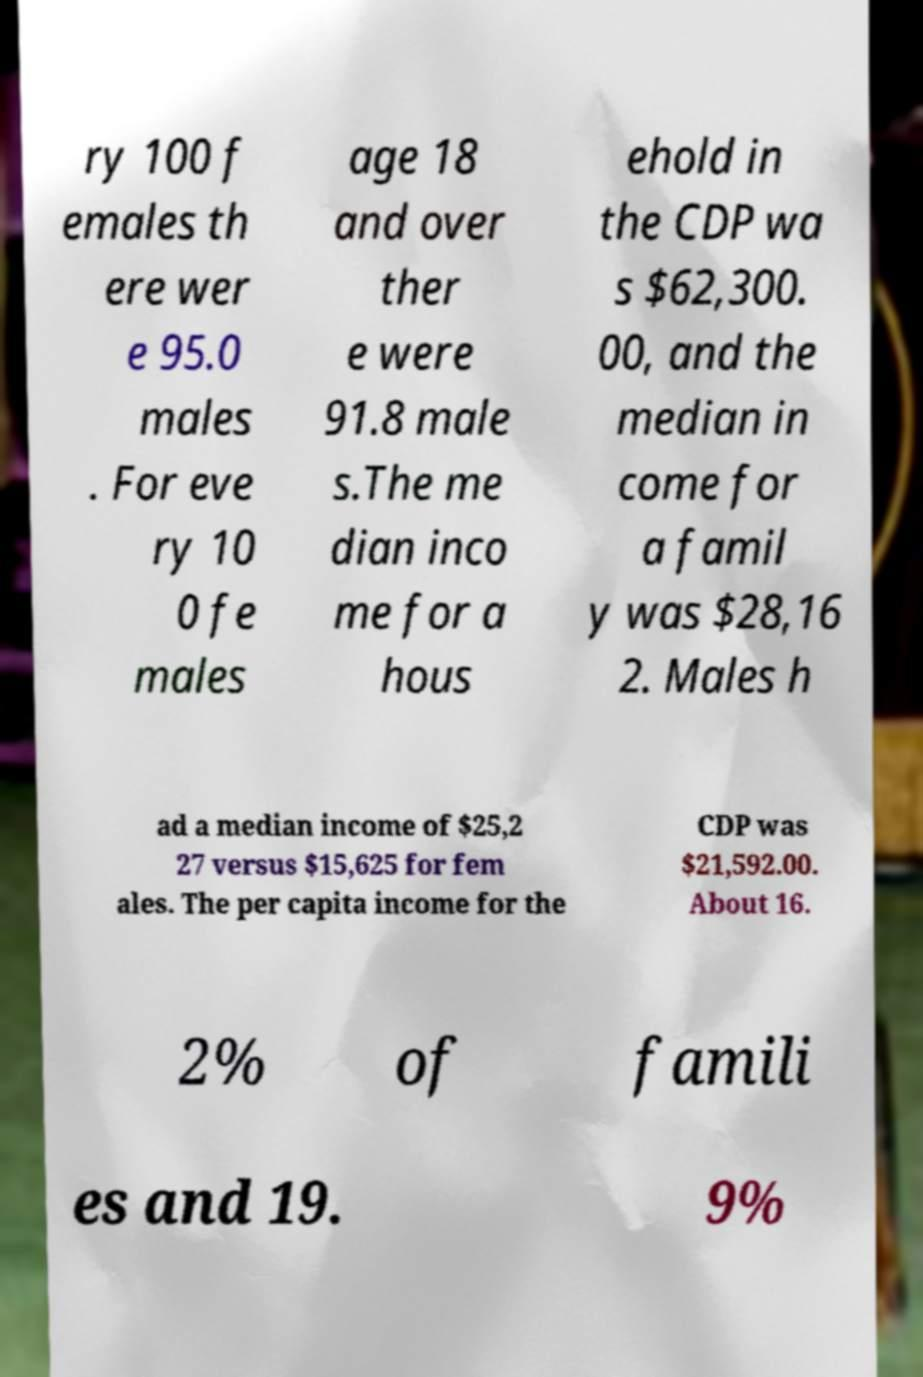For documentation purposes, I need the text within this image transcribed. Could you provide that? ry 100 f emales th ere wer e 95.0 males . For eve ry 10 0 fe males age 18 and over ther e were 91.8 male s.The me dian inco me for a hous ehold in the CDP wa s $62,300. 00, and the median in come for a famil y was $28,16 2. Males h ad a median income of $25,2 27 versus $15,625 for fem ales. The per capita income for the CDP was $21,592.00. About 16. 2% of famili es and 19. 9% 